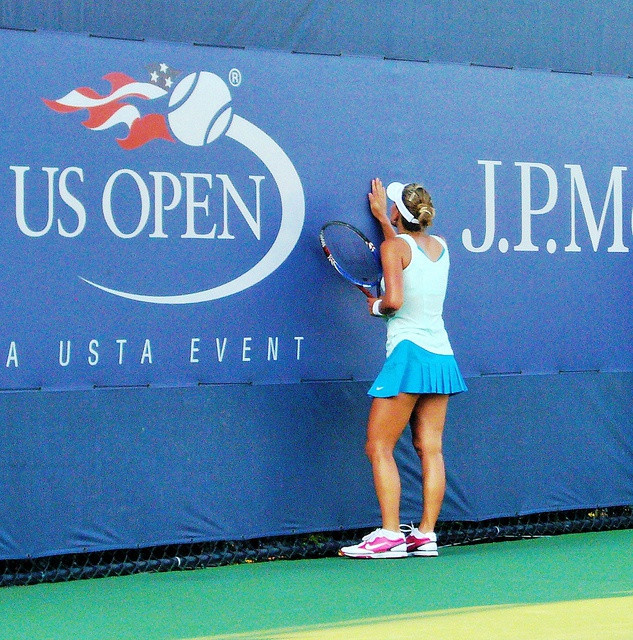Describe the objects in this image and their specific colors. I can see people in gray, lightblue, and tan tones and tennis racket in gray, blue, and navy tones in this image. 